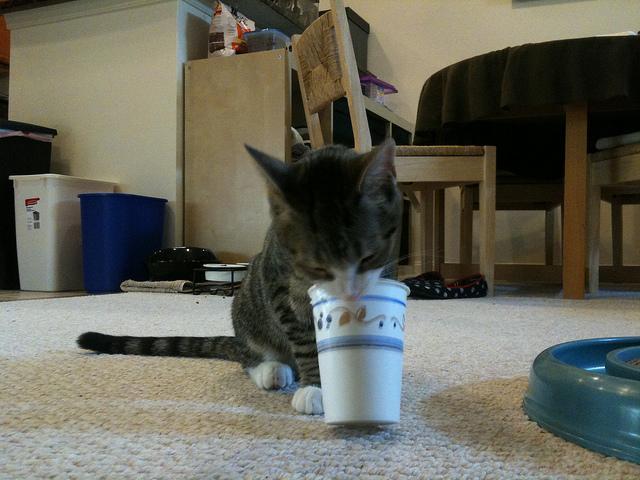How many trash cans do you see?
Give a very brief answer. 3. How many chairs are there?
Give a very brief answer. 2. How many people are wearing a green shirt?
Give a very brief answer. 0. 